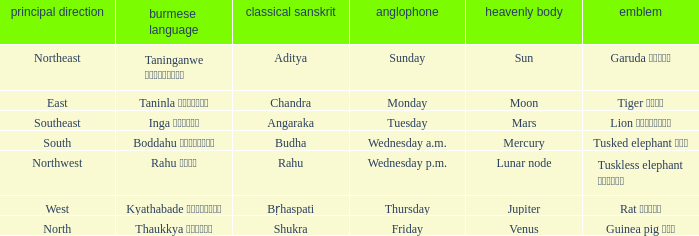What is the Burmese term for Thursday? Kyathabade ကြာသပတေး. 